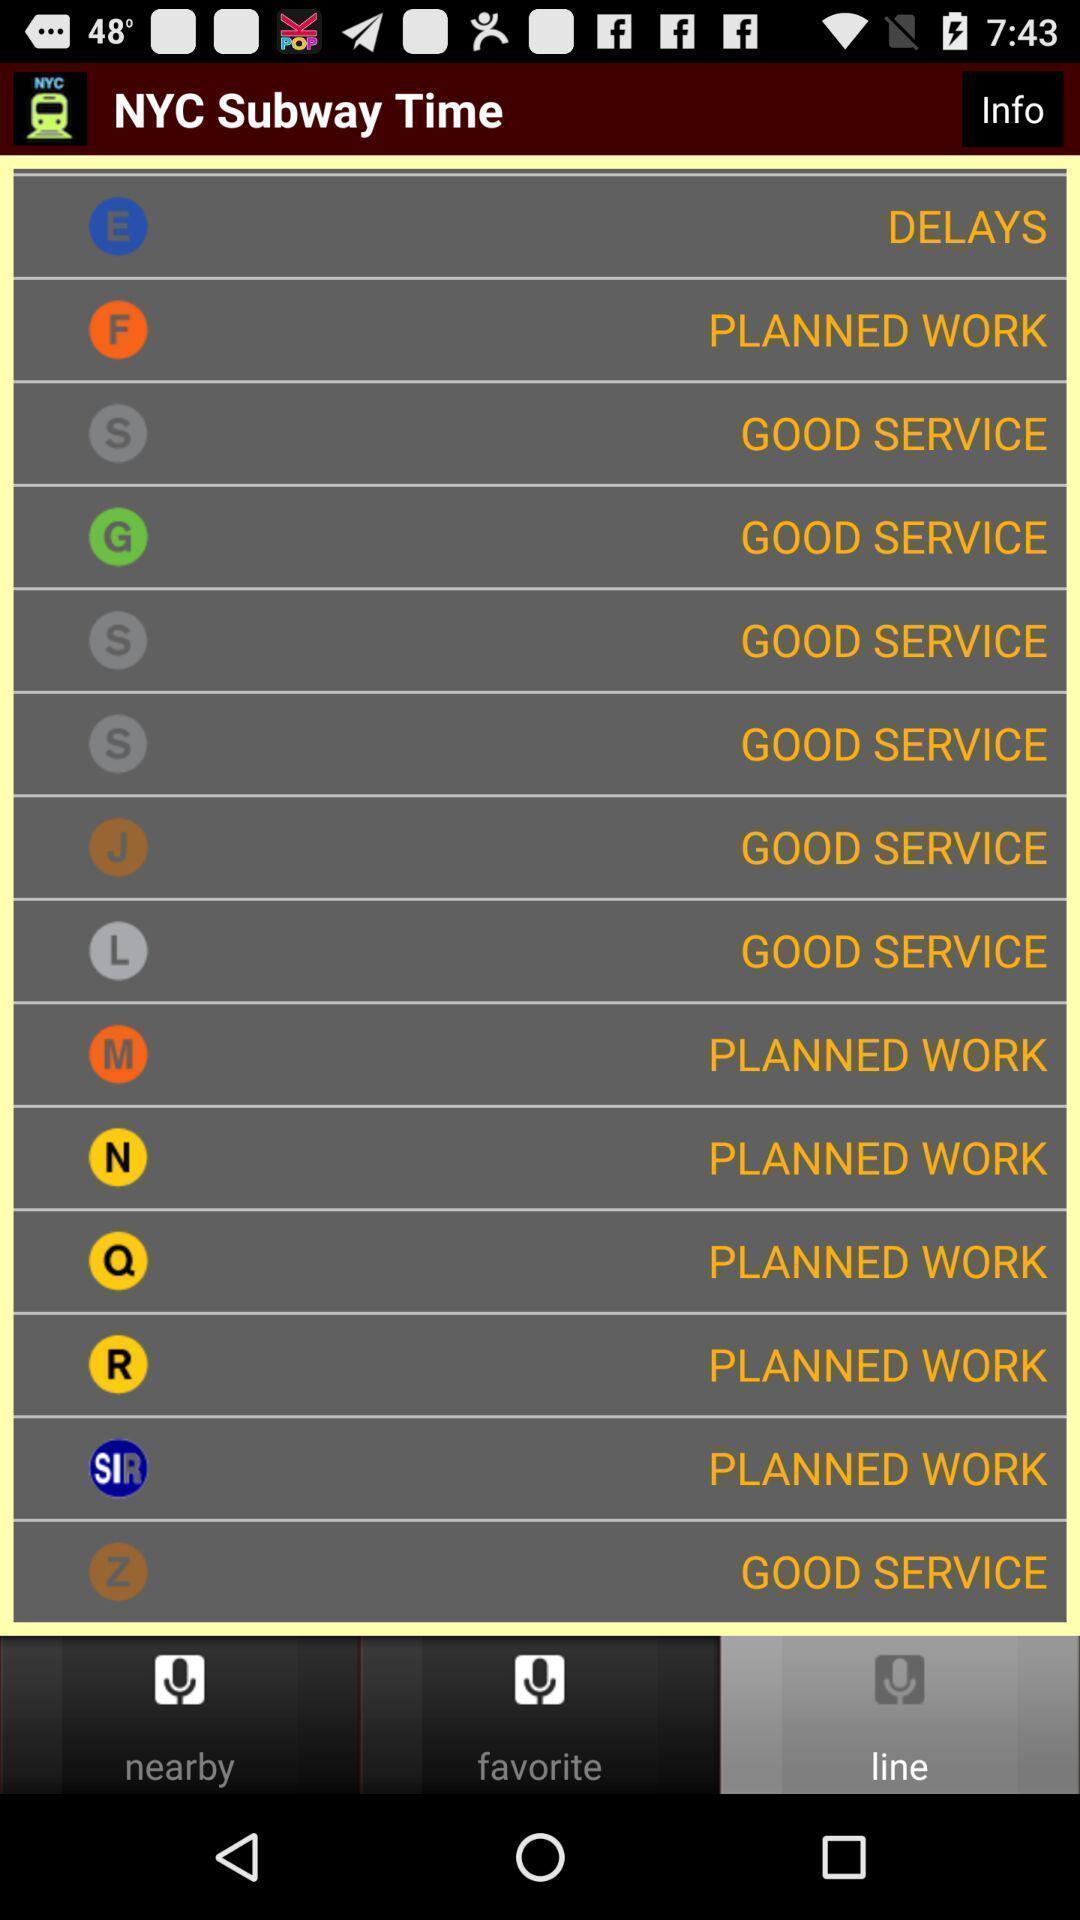Describe the key features of this screenshot. Page displaying list of train services. 